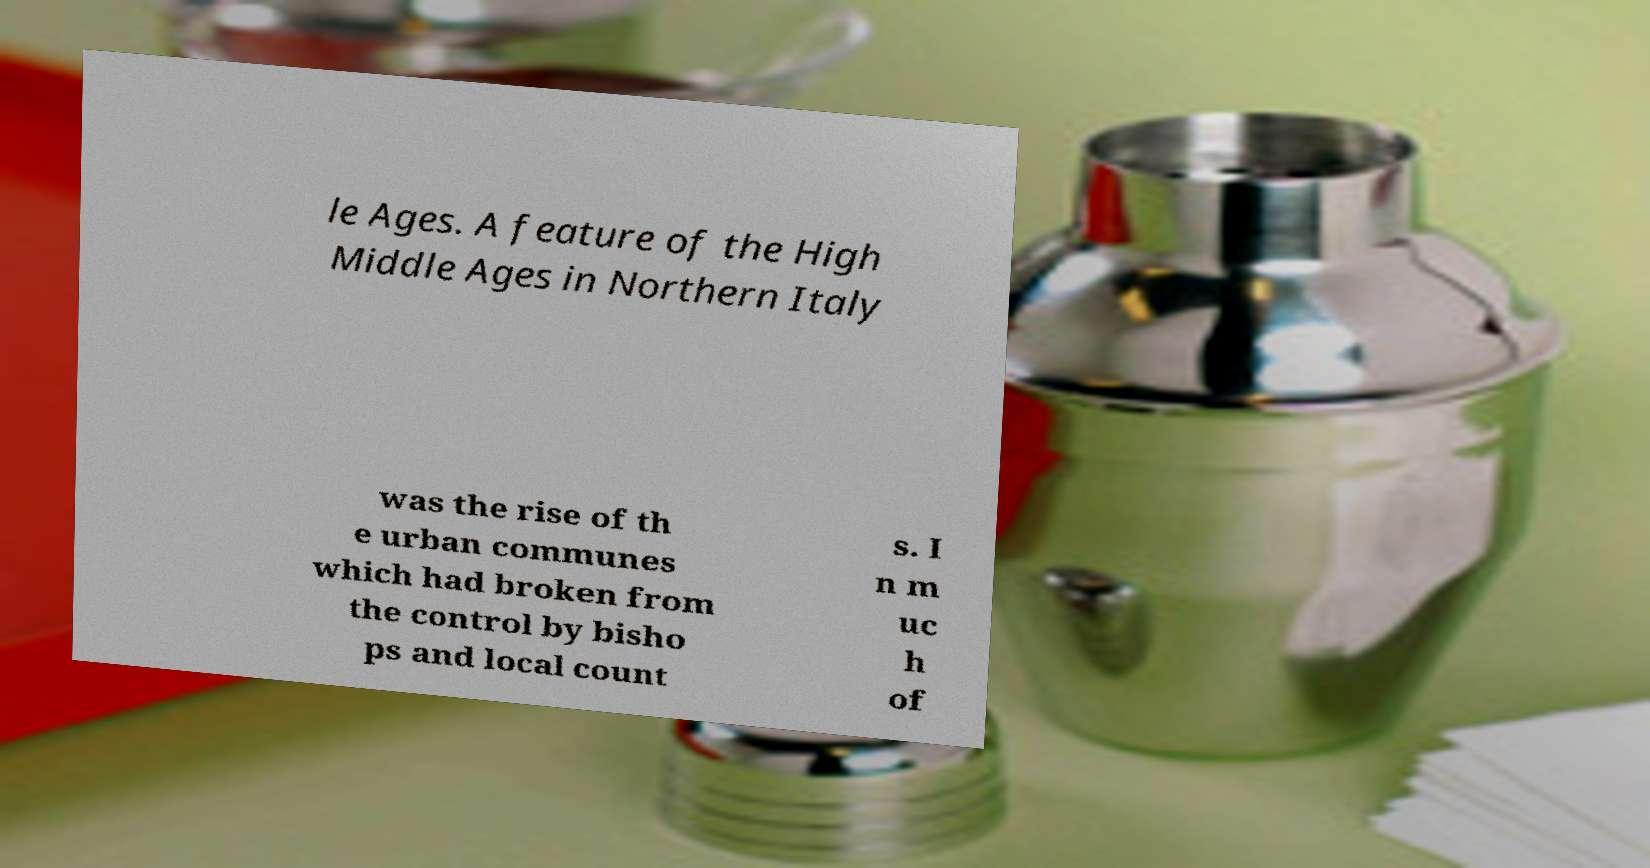Could you assist in decoding the text presented in this image and type it out clearly? le Ages. A feature of the High Middle Ages in Northern Italy was the rise of th e urban communes which had broken from the control by bisho ps and local count s. I n m uc h of 